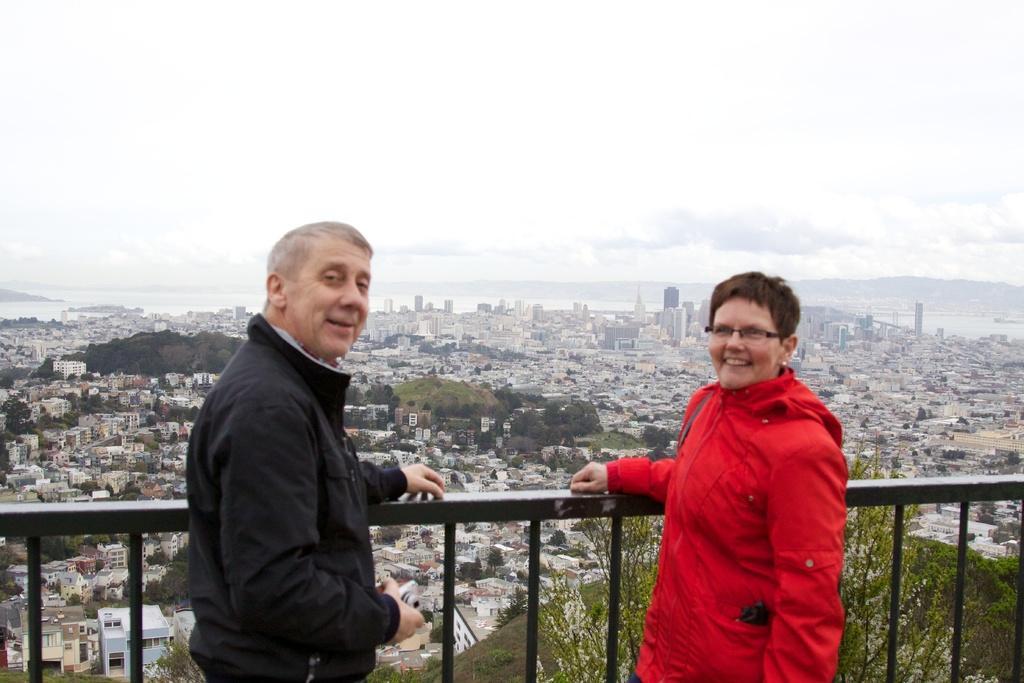Please provide a concise description of this image. On the left side a man is standing, he wore black color coat. On the right side a woman is standing, she wore red color coat, there are buildings and houses in the middle of an image. At the top it is the cloudy sky. 